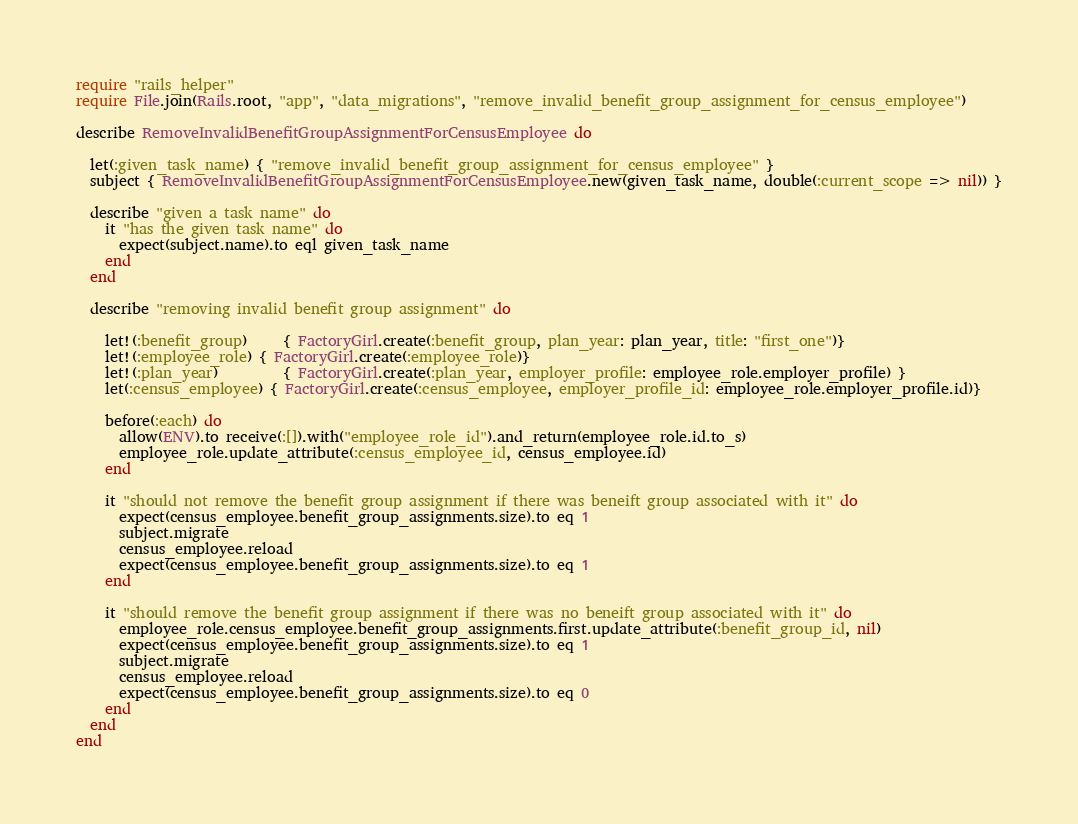<code> <loc_0><loc_0><loc_500><loc_500><_Ruby_>require "rails_helper"
require File.join(Rails.root, "app", "data_migrations", "remove_invalid_benefit_group_assignment_for_census_employee")

describe RemoveInvalidBenefitGroupAssignmentForCensusEmployee do

  let(:given_task_name) { "remove_invalid_benefit_group_assignment_for_census_employee" }
  subject { RemoveInvalidBenefitGroupAssignmentForCensusEmployee.new(given_task_name, double(:current_scope => nil)) }

  describe "given a task name" do
    it "has the given task name" do
      expect(subject.name).to eql given_task_name
    end
  end

  describe "removing invalid benefit group assignment" do

    let!(:benefit_group)     { FactoryGirl.create(:benefit_group, plan_year: plan_year, title: "first_one")}
    let!(:employee_role) { FactoryGirl.create(:employee_role)}
    let!(:plan_year)         { FactoryGirl.create(:plan_year, employer_profile: employee_role.employer_profile) }
    let(:census_employee) { FactoryGirl.create(:census_employee, employer_profile_id: employee_role.employer_profile.id)}

    before(:each) do
      allow(ENV).to receive(:[]).with("employee_role_id").and_return(employee_role.id.to_s)
      employee_role.update_attribute(:census_employee_id, census_employee.id)
    end

    it "should not remove the benefit group assignment if there was beneift group associated with it" do
      expect(census_employee.benefit_group_assignments.size).to eq 1
      subject.migrate
      census_employee.reload
      expect(census_employee.benefit_group_assignments.size).to eq 1
    end

    it "should remove the benefit group assignment if there was no beneift group associated with it" do
      employee_role.census_employee.benefit_group_assignments.first.update_attribute(:benefit_group_id, nil)
      expect(census_employee.benefit_group_assignments.size).to eq 1
      subject.migrate
      census_employee.reload
      expect(census_employee.benefit_group_assignments.size).to eq 0
    end
  end
end
</code> 